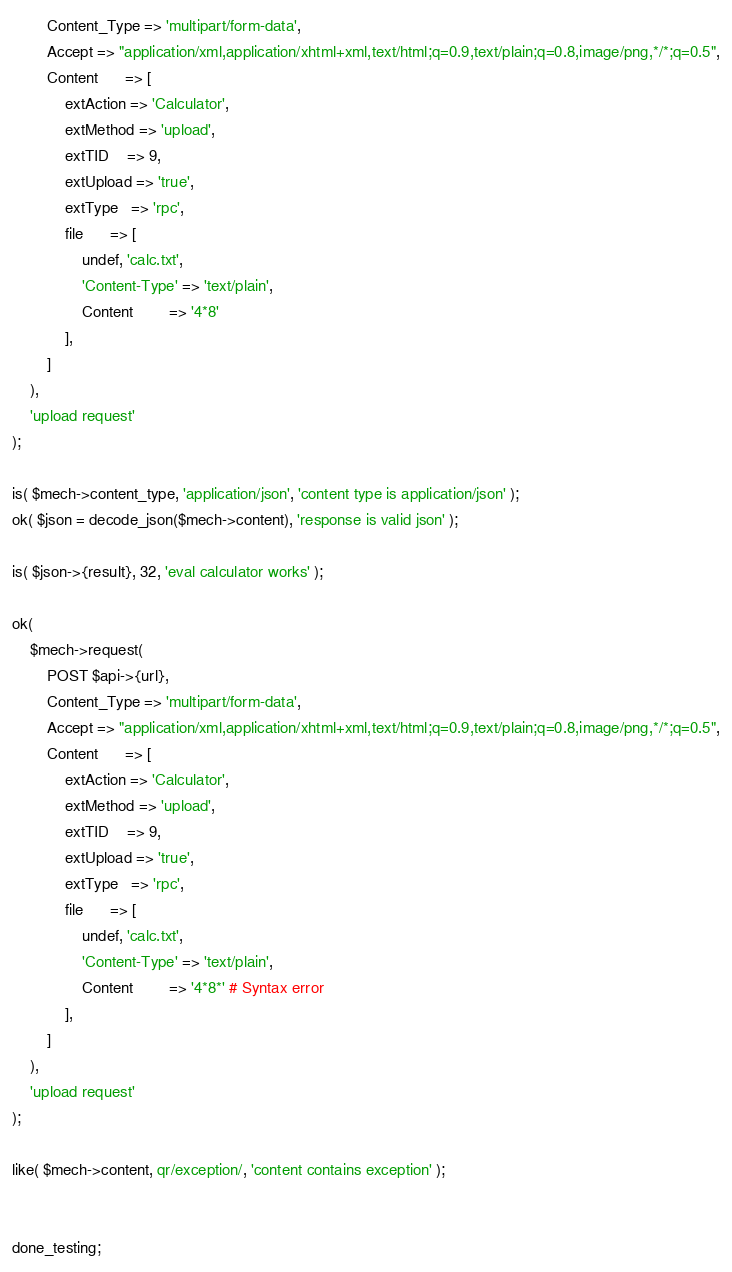<code> <loc_0><loc_0><loc_500><loc_500><_Perl_>        Content_Type => 'multipart/form-data',
        Accept => "application/xml,application/xhtml+xml,text/html;q=0.9,text/plain;q=0.8,image/png,*/*;q=0.5",
        Content      => [
            extAction => 'Calculator',
            extMethod => 'upload',
            extTID    => 9,
            extUpload => 'true',
            extType   => 'rpc',
            file      => [
                undef, 'calc.txt',
                'Content-Type' => 'text/plain',
                Content        => '4*8'
            ],
        ]
    ),
    'upload request'
);

is( $mech->content_type, 'application/json', 'content type is application/json' );
ok( $json = decode_json($mech->content), 'response is valid json' );

is( $json->{result}, 32, 'eval calculator works' );

ok(
    $mech->request(
        POST $api->{url},
        Content_Type => 'multipart/form-data',
        Accept => "application/xml,application/xhtml+xml,text/html;q=0.9,text/plain;q=0.8,image/png,*/*;q=0.5",
        Content      => [
            extAction => 'Calculator',
            extMethod => 'upload',
            extTID    => 9,
            extUpload => 'true',
            extType   => 'rpc',
            file      => [
                undef, 'calc.txt',
                'Content-Type' => 'text/plain',
                Content        => '4*8*' # Syntax error
            ],
        ]
    ),
    'upload request'
);

like( $mech->content, qr/exception/, 'content contains exception' );


done_testing;
</code> 